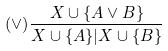Convert formula to latex. <formula><loc_0><loc_0><loc_500><loc_500>( \vee ) \frac { X \cup \{ A \vee B \} } { X \cup \{ A \} | X \cup \{ B \} }</formula> 